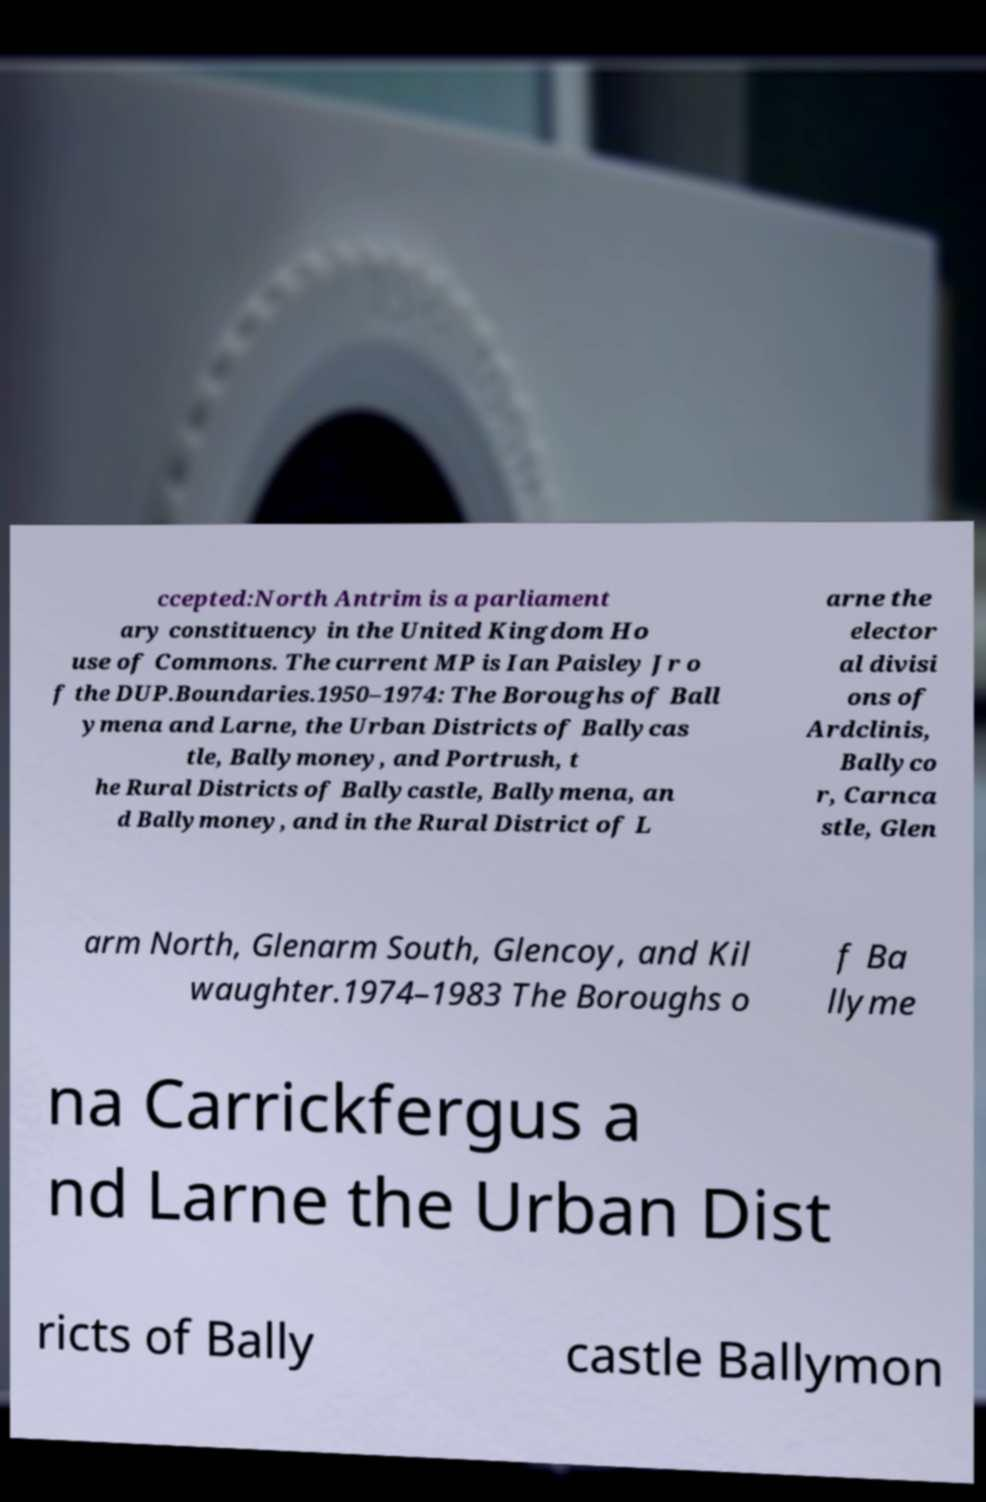Could you extract and type out the text from this image? ccepted:North Antrim is a parliament ary constituency in the United Kingdom Ho use of Commons. The current MP is Ian Paisley Jr o f the DUP.Boundaries.1950–1974: The Boroughs of Ball ymena and Larne, the Urban Districts of Ballycas tle, Ballymoney, and Portrush, t he Rural Districts of Ballycastle, Ballymena, an d Ballymoney, and in the Rural District of L arne the elector al divisi ons of Ardclinis, Ballyco r, Carnca stle, Glen arm North, Glenarm South, Glencoy, and Kil waughter.1974–1983 The Boroughs o f Ba llyme na Carrickfergus a nd Larne the Urban Dist ricts of Bally castle Ballymon 